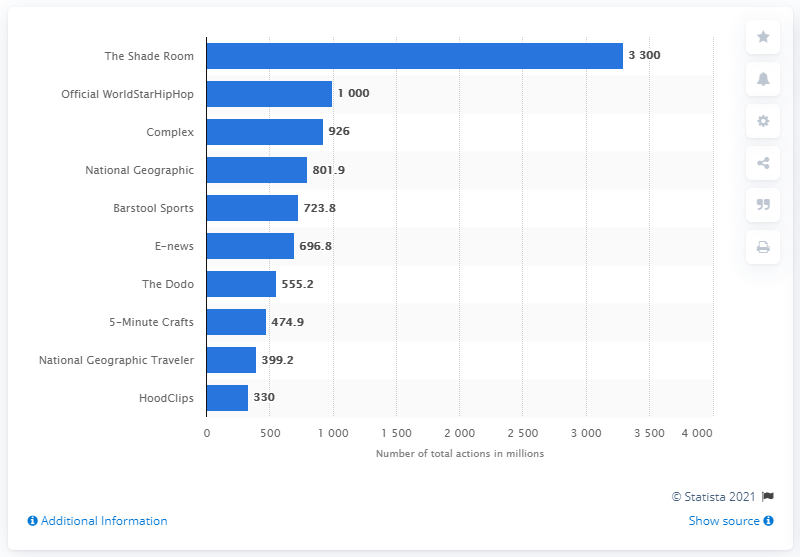Draw attention to some important aspects in this diagram. In 2020, the Shade Room had a total of 3,300 video content actions. According to user engagement statistics, the second most popular music platform was Official WorldStarHipHop. 